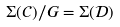<formula> <loc_0><loc_0><loc_500><loc_500>\Sigma ( \mathcal { C } ) / G = \Sigma ( \mathcal { D } )</formula> 